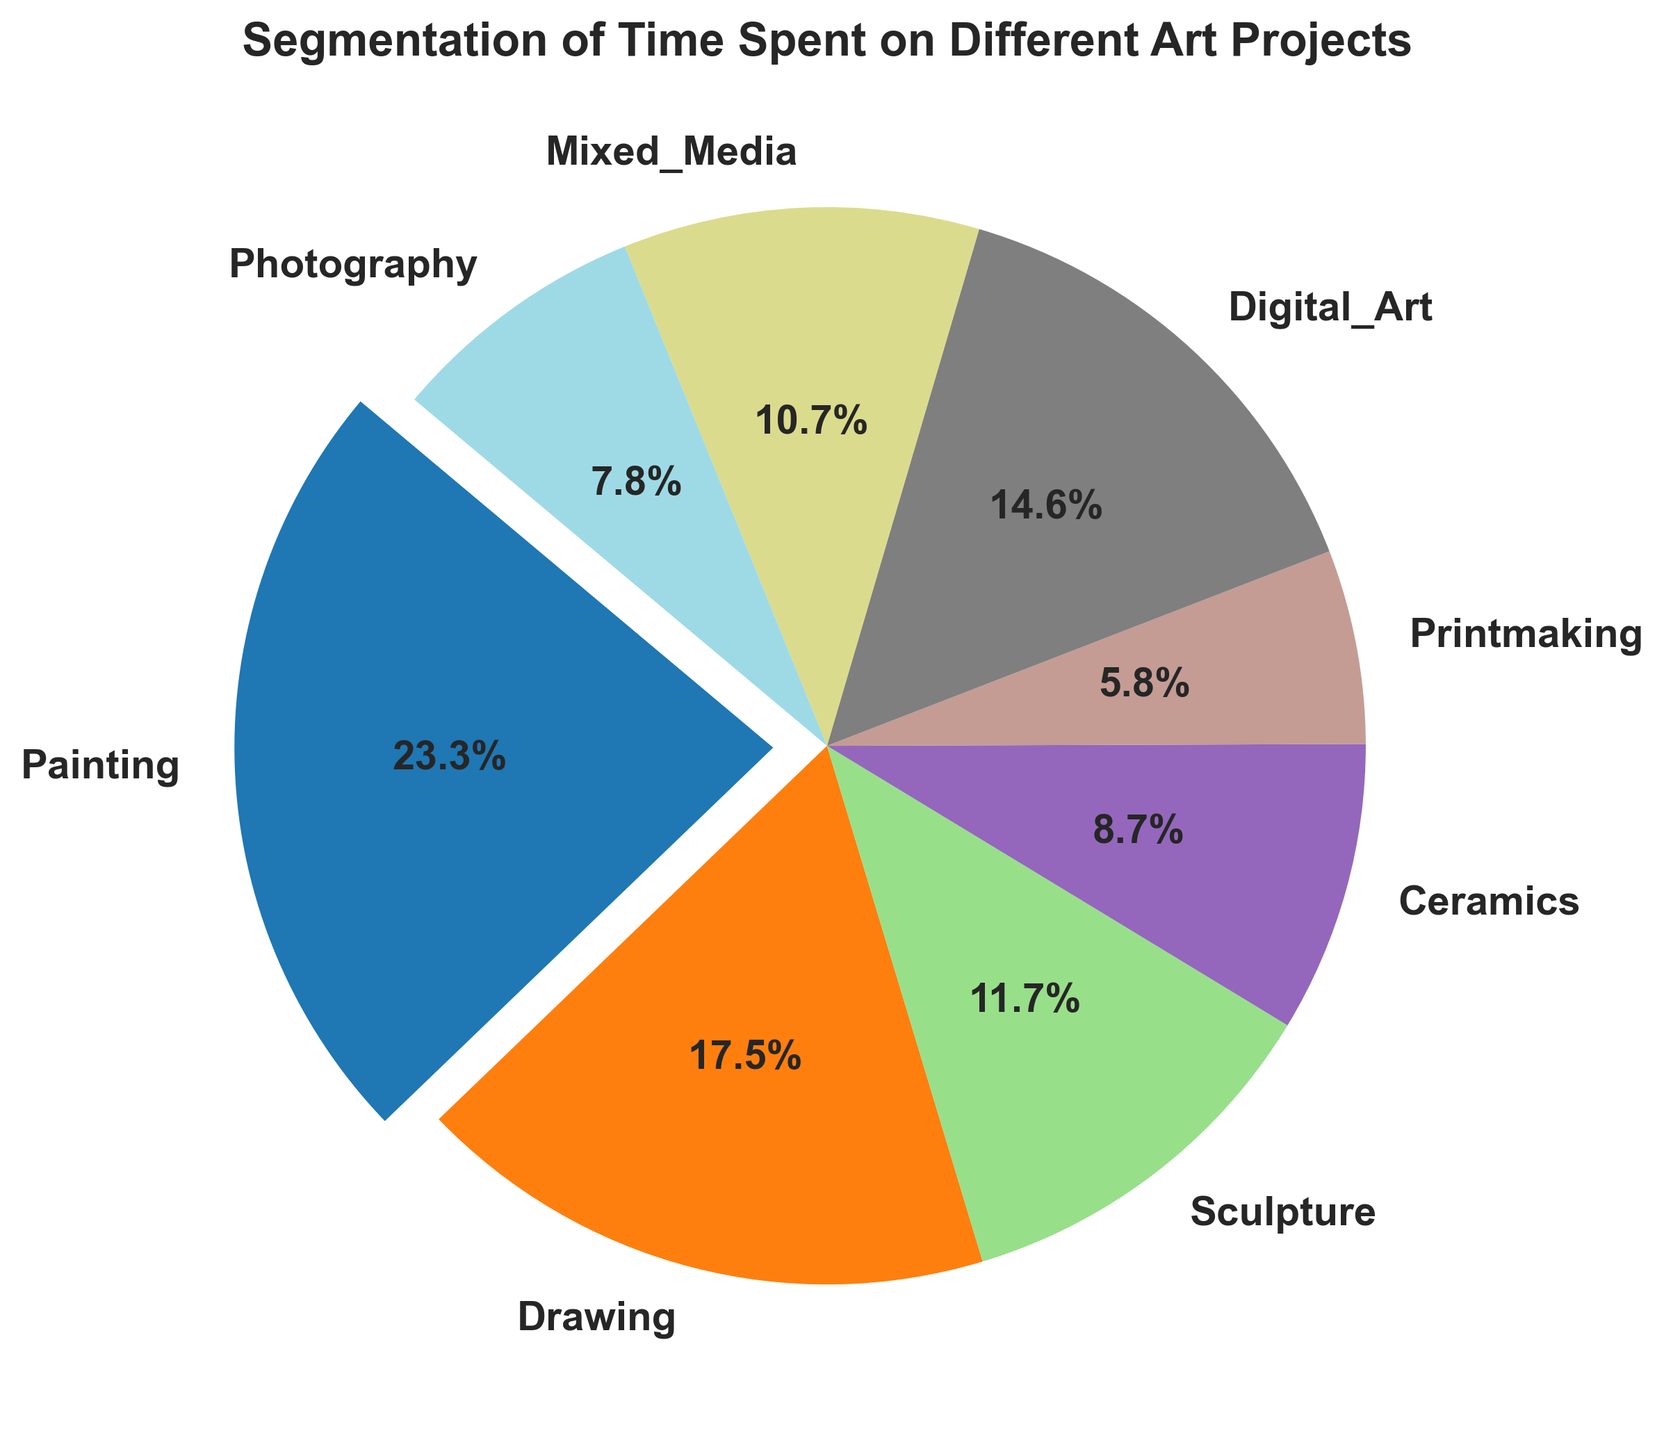Which art project had the highest percentage of hours spent? The largest slice of the pie will indicate the project with the highest percentage. This is also the segment that is exploded out in the chart for emphasis.
Answer: Painting What percentage of time was spent on Digital Art? Look for the segment labeled "Digital Art" on the pie chart and note the percentage displayed next to it.
Answer: 15.0% How much more time was spent on Painting compared to Sculpture? Find the hours spent on Painting (120 hours) and Sculpture (60 hours), then calculate the difference: 120 - 60.
Answer: 60 hours Which art project had the smallest percentage of hours spent? The smallest slice of the pie will indicate the project with the smallest percentage.
Answer: Printmaking Which two projects combined account for more than 50% of the total time spent? Identify the projects with the largest percentages and add their values until the sum exceeds 50%. Painting (26.7%) + Drawing (20.0%) = 46.7%; Painting (26.7%) + Digital Art (16.7%) = 42.7%; Painting (26.7%) + Drawing (20.0%) + Digital Art (16.7%) = 63.4%. The pair is Painting and Drawing, as they combined reach 46.7%. Add Digital Art to any of these to easily cross above 50%.
Answer: Painting and Digital Art How many more hours were spent on Painting compared to the total hours spent on Ceramics and Photography? Calculate the sum of hours spent on Ceramics (45 hours) and Photography (40 hours), then subtract this total from the hours spent on Painting (120 hours): 120 - (45 + 40).
Answer: 35 hours Are there any two projects that combined account for the same percentage of time as Digital Art alone? Digital Art is 15.0%. Look for any combination of two projects that together make 15%. Mixed Media (12.2%) + Photography (8.9%) = 21.1%, and so on—they do not match 15.0%.
Answer: No Which project accounts for approximately one-third of the total hours spent on Sculpture? Divide the hours spent on Sculpture (60 hours) by 3 to find one-third of this value, then check which project closely matches this number. One-third of Sculpture is 20 hours, and none of the other projects are this close.
Answer: None What is the average percentage of time spent on Ceramics and Printmaking? Find the percentages of time spent on Ceramics (10.0%) and Printmaking (6.7%), then calculate the average: (10.0 + 6.7) / 2.
Answer: 8.35% Which projects have percentages above 10%? Locate each segment on the pie chart with a percentage higher than 10%. These are Painting (26.7%), Drawing (20.0%), Digital Art (15.0%), and Sculpture (13.3%).
Answer: Painting, Drawing, Digital Art, and Sculpture 